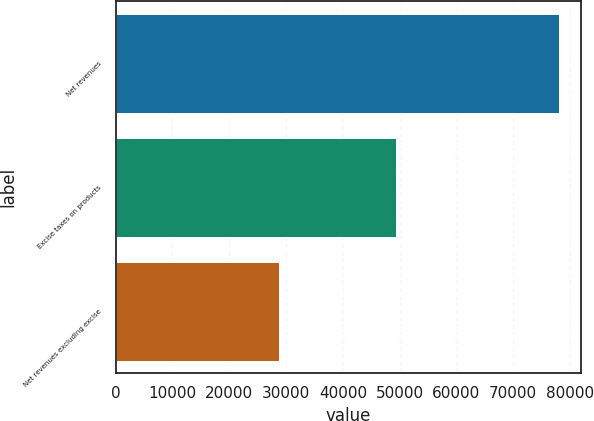Convert chart. <chart><loc_0><loc_0><loc_500><loc_500><bar_chart><fcel>Net revenues<fcel>Excise taxes on products<fcel>Net revenues excluding excise<nl><fcel>78098<fcel>49350<fcel>28748<nl></chart> 